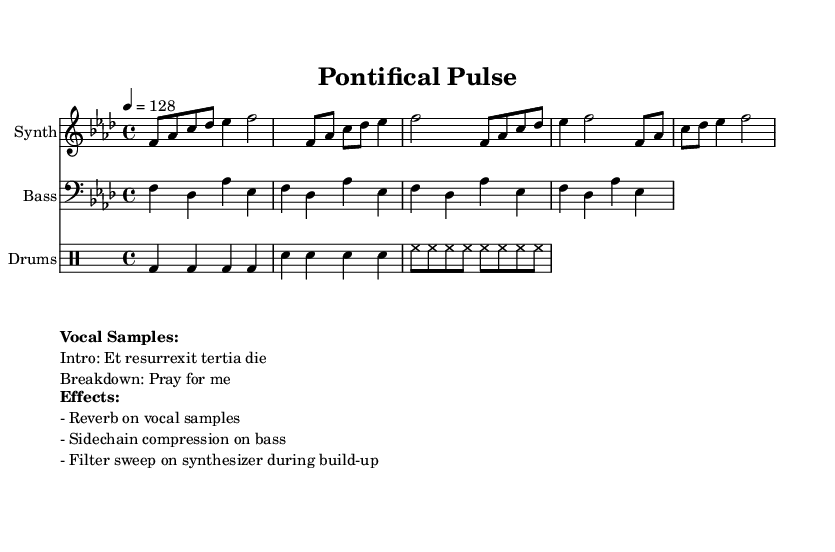What is the key signature of this music? The key signature is F minor, which has four flats (B♭, E♭, A♭, and D♭) based on the provided music data.
Answer: F minor What is the time signature of this music? The time signature is 4/4, meaning there are four beats in each measure, which is indicated in the global section of the code.
Answer: 4/4 What is the tempo marking of this music? The tempo marking shows "4 = 128," indicating that there are 128 beats per minute, established in the global section of the music.
Answer: 128 Which instrument plays the bass part? The bass part is written in the bass clef, indicating that it is meant for a bass instrument, as seen in the score layout where it is labeled as "Bass."
Answer: Bass What type of effects are used on the vocal samples? The effects applied to the vocal samples include reverb. This is mentioned in the "Effects" section of the markup.
Answer: Reverb How many measures are present in the synthesizer part? The synthesizer part consists of four measures, as deduced from the visible structure of notes grouped in the provided data.
Answer: Four What vocal sample is used in the intro? The vocal sample in the intro is "Et resurrexit tertia die," which is explicitly cited in the "Vocal Samples" markup section.
Answer: Et resurrexit tertia die 